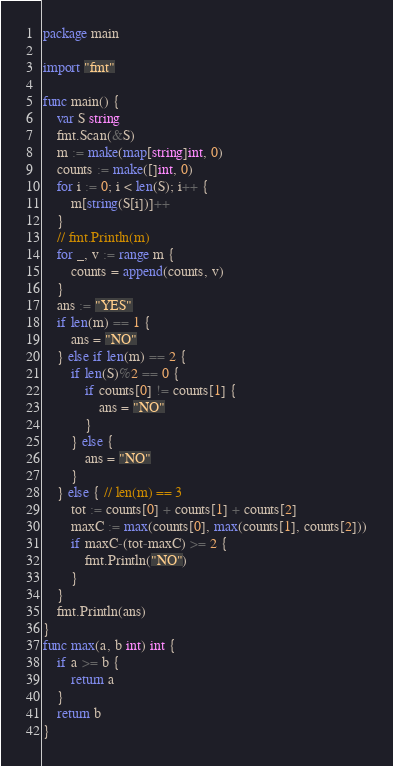<code> <loc_0><loc_0><loc_500><loc_500><_Go_>package main

import "fmt"

func main() {
	var S string
	fmt.Scan(&S)
	m := make(map[string]int, 0)
	counts := make([]int, 0)
	for i := 0; i < len(S); i++ {
		m[string(S[i])]++
	}
	// fmt.Println(m)
	for _, v := range m {
		counts = append(counts, v)
	}
	ans := "YES"
	if len(m) == 1 {
		ans = "NO"
	} else if len(m) == 2 {
		if len(S)%2 == 0 {
			if counts[0] != counts[1] {
				ans = "NO"
			}
		} else {
			ans = "NO"
		}
	} else { // len(m) == 3
		tot := counts[0] + counts[1] + counts[2]
		maxC := max(counts[0], max(counts[1], counts[2]))
		if maxC-(tot-maxC) >= 2 {
			fmt.Println("NO")
		}
	}
	fmt.Println(ans)
}
func max(a, b int) int {
	if a >= b {
		return a
	}
	return b
}
</code> 